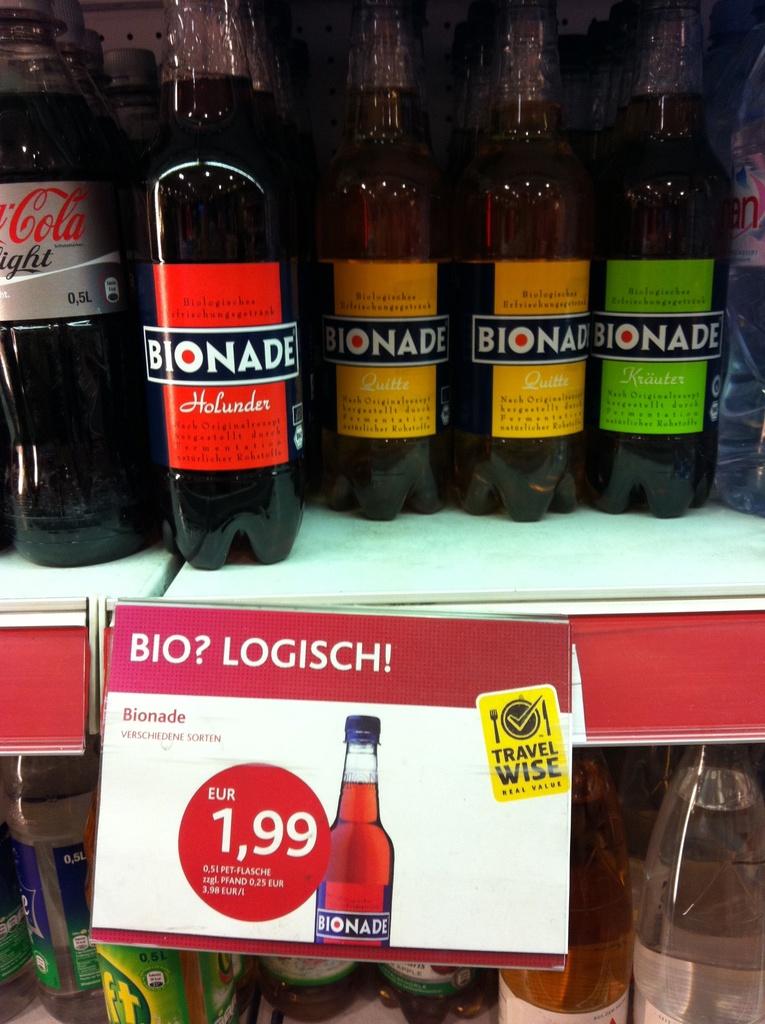How much is that drink?
Provide a short and direct response. 1,99. What is the brand name of this drink?
Provide a succinct answer. Bionade. 